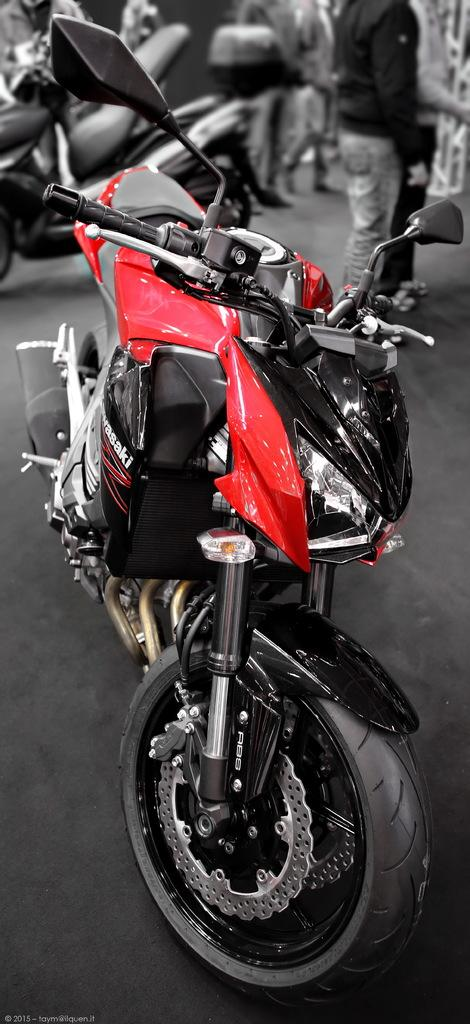What type of vehicles are in the image? There are bikes in the image. Can you describe the people in the image? There are persons in the image. What can be seen in the background on the right side of the image? There is an object in the background on the right side of the image. What is the color of the object in the background? The object is white in color. What type of pail is being used by the persons in the image? There is no pail present in the image. How many spoons can be seen in the hands of the persons in the image? There are no spoons visible in the image. 